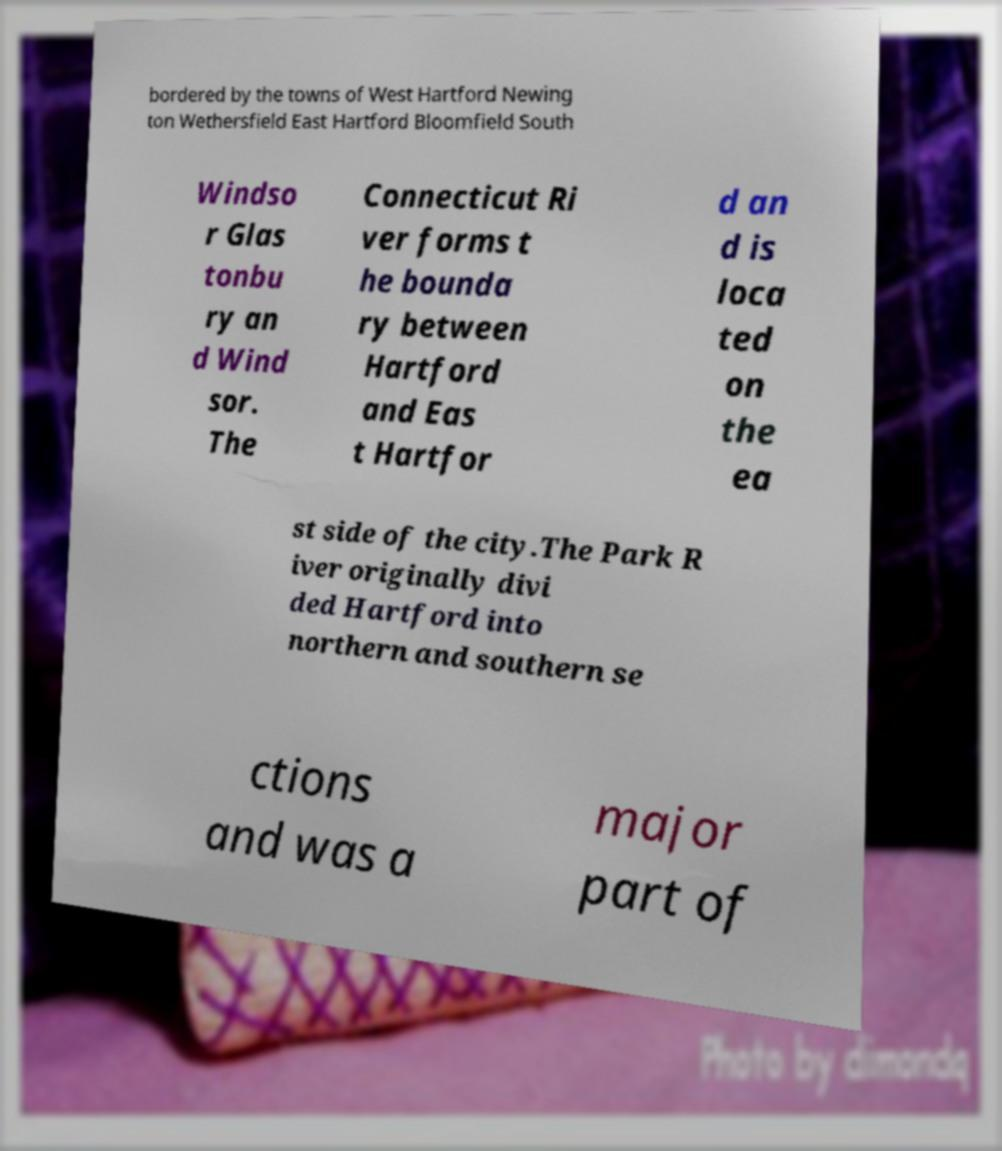I need the written content from this picture converted into text. Can you do that? bordered by the towns of West Hartford Newing ton Wethersfield East Hartford Bloomfield South Windso r Glas tonbu ry an d Wind sor. The Connecticut Ri ver forms t he bounda ry between Hartford and Eas t Hartfor d an d is loca ted on the ea st side of the city.The Park R iver originally divi ded Hartford into northern and southern se ctions and was a major part of 